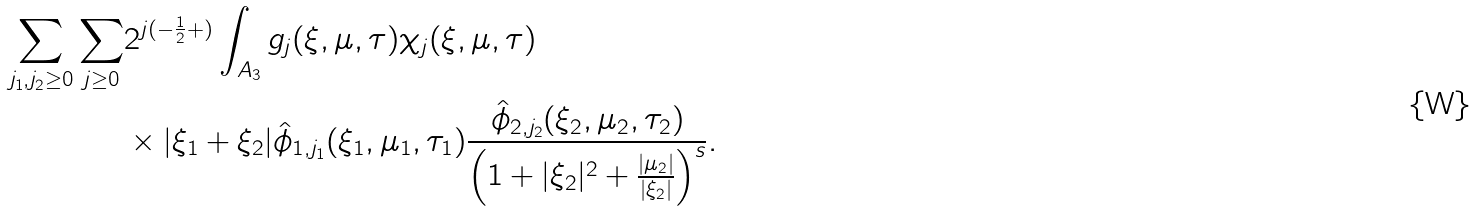<formula> <loc_0><loc_0><loc_500><loc_500>\sum _ { j _ { 1 } , j _ { 2 } \geq 0 } \sum _ { j \geq 0 } & 2 ^ { j ( - \frac { 1 } { 2 } + ) } \int _ { A _ { 3 } } g _ { j } ( \xi , \mu , \tau ) \chi _ { j } ( \xi , \mu , \tau ) \\ & \times | \xi _ { 1 } + \xi _ { 2 } | \hat { \phi } _ { 1 , j _ { 1 } } ( \xi _ { 1 } , \mu _ { 1 } , \tau _ { 1 } ) \frac { \hat { \phi } _ { 2 , j _ { 2 } } ( \xi _ { 2 } , \mu _ { 2 } , \tau _ { 2 } ) } { \left ( 1 + | \xi _ { 2 } | ^ { 2 } + \frac { | \mu _ { 2 } | } { | \xi _ { 2 } | } \right ) ^ { s } } .</formula> 